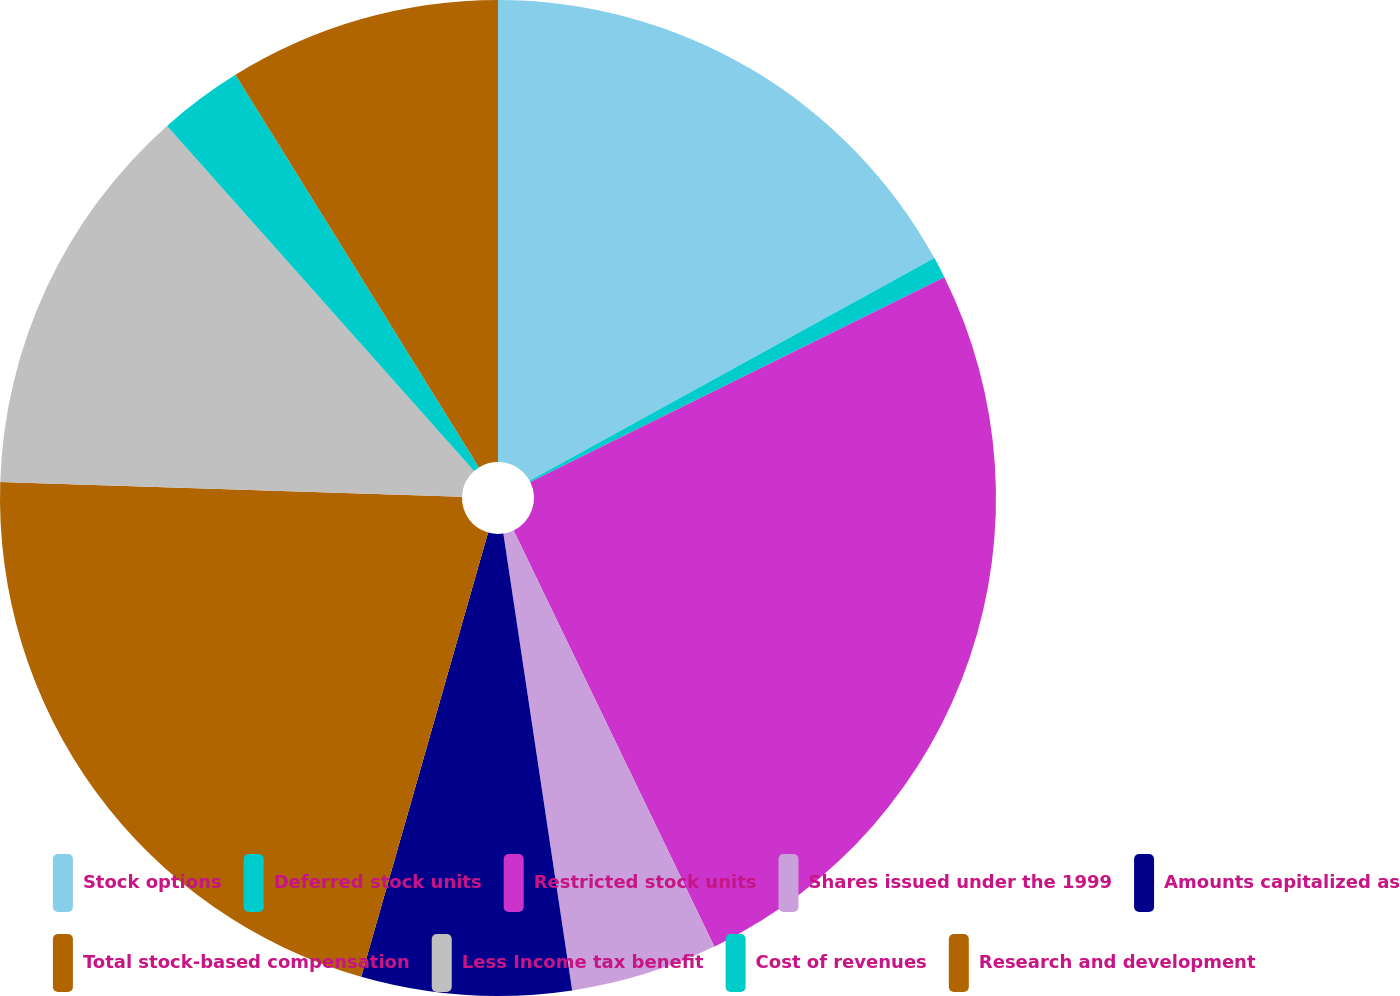Convert chart to OTSL. <chart><loc_0><loc_0><loc_500><loc_500><pie_chart><fcel>Stock options<fcel>Deferred stock units<fcel>Restricted stock units<fcel>Shares issued under the 1999<fcel>Amounts capitalized as<fcel>Total stock-based compensation<fcel>Less Income tax benefit<fcel>Cost of revenues<fcel>Research and development<nl><fcel>17.0%<fcel>0.69%<fcel>25.16%<fcel>4.77%<fcel>6.81%<fcel>21.08%<fcel>12.92%<fcel>2.73%<fcel>8.84%<nl></chart> 